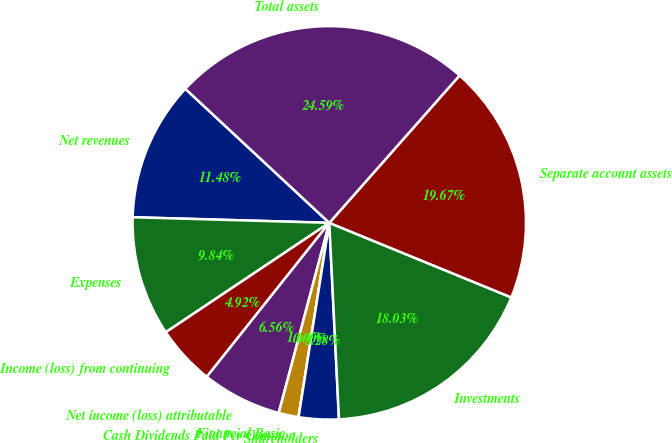Convert chart to OTSL. <chart><loc_0><loc_0><loc_500><loc_500><pie_chart><fcel>Net revenues<fcel>Expenses<fcel>Income (loss) from continuing<fcel>Net income (loss) attributable<fcel>Financial Basic<fcel>Cash Dividends Paid Per Common<fcel>Shareholders<fcel>Investments<fcel>Separate account assets<fcel>Total assets<nl><fcel>11.48%<fcel>9.84%<fcel>4.92%<fcel>6.56%<fcel>1.64%<fcel>0.0%<fcel>3.28%<fcel>18.03%<fcel>19.67%<fcel>24.59%<nl></chart> 